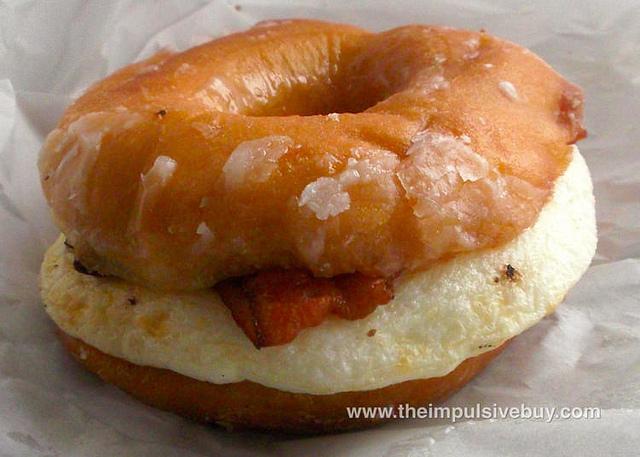What is this food?
Answer briefly. Breakfast sandwich. Is this healthy?
Write a very short answer. No. Is there any fruit on this sandwich?
Quick response, please. No. 